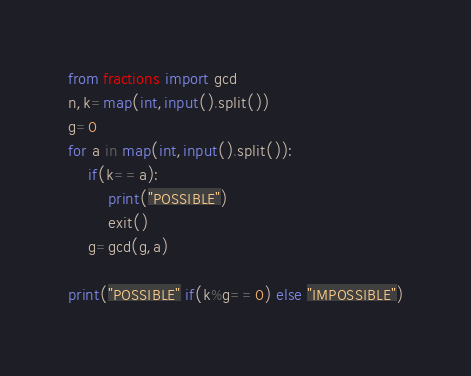<code> <loc_0><loc_0><loc_500><loc_500><_Python_>from fractions import gcd
n,k=map(int,input().split())
g=0
for a in map(int,input().split()):
    if(k==a):
        print("POSSIBLE")
        exit()
    g=gcd(g,a)

print("POSSIBLE" if(k%g==0) else "IMPOSSIBLE")</code> 